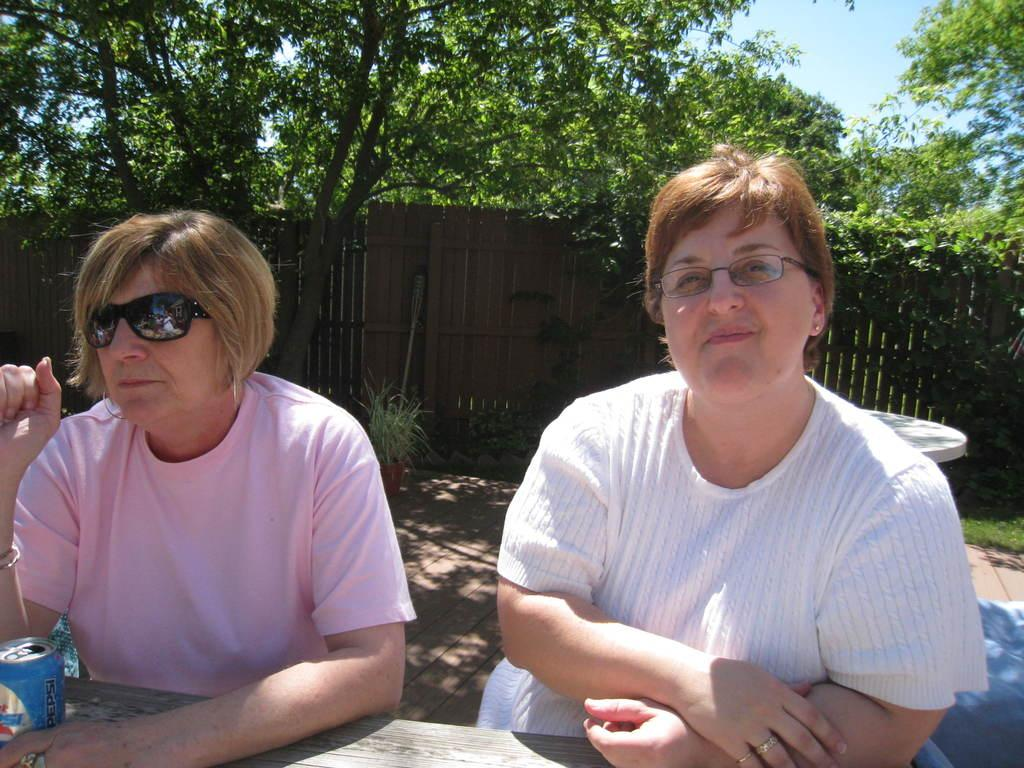How many people are sitting in the image? There are two women sitting in the image. What is on the table in the image? There is a tin on a table in the image. What type of plant is on the ground in the image? There is a house plant on the ground in the image. What can be seen on the wall in the image? The wall is visible in the image, but there is no specific detail mentioned about it. What is visible in the background of the image? There are trees and the sky visible in the background of the image. What type of jam is being spread on the edge of the tin in the image? There is no jam or any indication of spreading in the image; it only shows two women sitting, a tin on a table, a house plant on the ground, a wall, trees, and the sky in the background. 